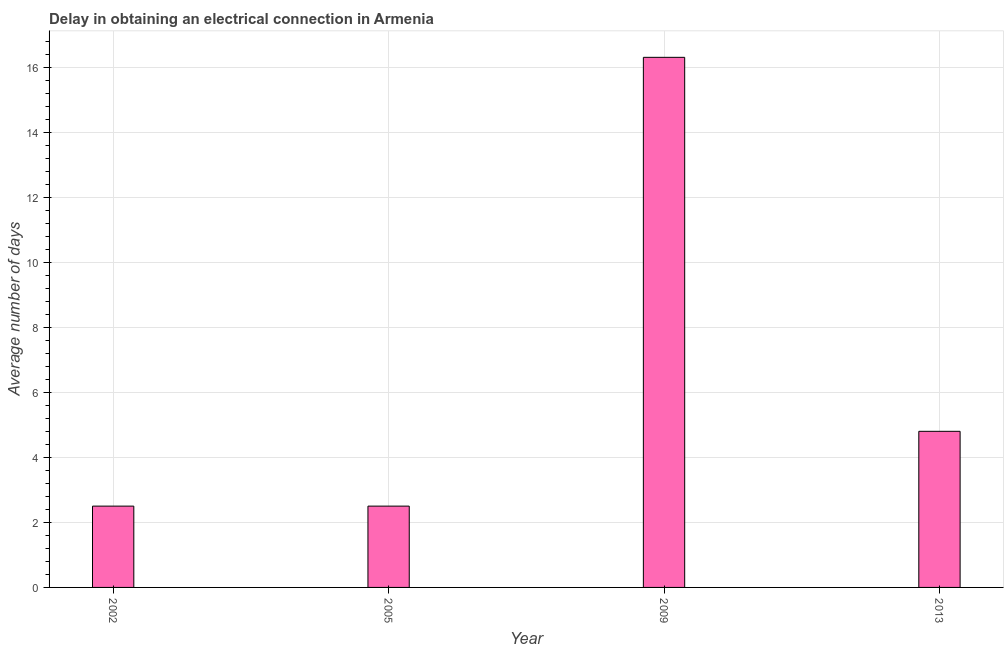Does the graph contain any zero values?
Your answer should be very brief. No. Does the graph contain grids?
Your response must be concise. Yes. What is the title of the graph?
Offer a terse response. Delay in obtaining an electrical connection in Armenia. What is the label or title of the X-axis?
Ensure brevity in your answer.  Year. What is the label or title of the Y-axis?
Make the answer very short. Average number of days. What is the dalay in electrical connection in 2009?
Make the answer very short. 16.3. Across all years, what is the minimum dalay in electrical connection?
Make the answer very short. 2.5. In which year was the dalay in electrical connection maximum?
Offer a very short reply. 2009. In which year was the dalay in electrical connection minimum?
Offer a very short reply. 2002. What is the sum of the dalay in electrical connection?
Your response must be concise. 26.1. What is the average dalay in electrical connection per year?
Make the answer very short. 6.53. What is the median dalay in electrical connection?
Give a very brief answer. 3.65. Do a majority of the years between 2009 and 2005 (inclusive) have dalay in electrical connection greater than 4 days?
Provide a short and direct response. No. Is the difference between the dalay in electrical connection in 2002 and 2013 greater than the difference between any two years?
Give a very brief answer. No. Is the sum of the dalay in electrical connection in 2002 and 2009 greater than the maximum dalay in electrical connection across all years?
Give a very brief answer. Yes. What is the difference between the highest and the lowest dalay in electrical connection?
Your response must be concise. 13.8. How many bars are there?
Give a very brief answer. 4. Are all the bars in the graph horizontal?
Keep it short and to the point. No. What is the difference between two consecutive major ticks on the Y-axis?
Make the answer very short. 2. Are the values on the major ticks of Y-axis written in scientific E-notation?
Make the answer very short. No. What is the Average number of days in 2002?
Your answer should be very brief. 2.5. What is the Average number of days of 2009?
Provide a succinct answer. 16.3. What is the difference between the Average number of days in 2002 and 2009?
Offer a very short reply. -13.8. What is the difference between the Average number of days in 2009 and 2013?
Your answer should be compact. 11.5. What is the ratio of the Average number of days in 2002 to that in 2005?
Offer a very short reply. 1. What is the ratio of the Average number of days in 2002 to that in 2009?
Offer a very short reply. 0.15. What is the ratio of the Average number of days in 2002 to that in 2013?
Ensure brevity in your answer.  0.52. What is the ratio of the Average number of days in 2005 to that in 2009?
Ensure brevity in your answer.  0.15. What is the ratio of the Average number of days in 2005 to that in 2013?
Ensure brevity in your answer.  0.52. What is the ratio of the Average number of days in 2009 to that in 2013?
Provide a succinct answer. 3.4. 